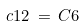Convert formula to latex. <formula><loc_0><loc_0><loc_500><loc_500>c 1 2 \, = \, C 6</formula> 